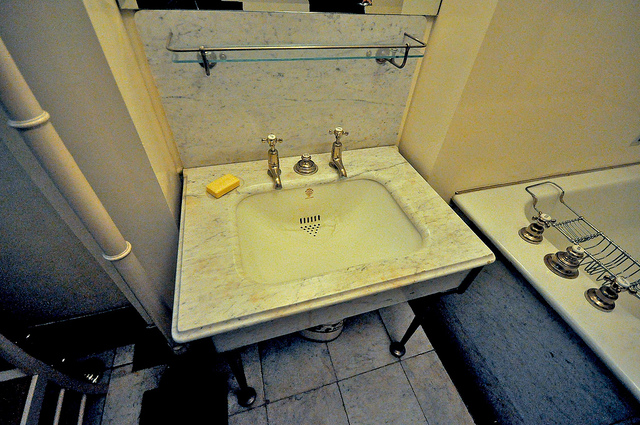How many knobs can you count on the sink and the bathtub? The image shows a total of eight knobs. There are three knobs on the sink: two for controlling the hot and cold water and one potentially for additional adjustments. The bathtub has five knobs, which might control various functions such as water flow, temperature, and perhaps a diverter for the shower. 